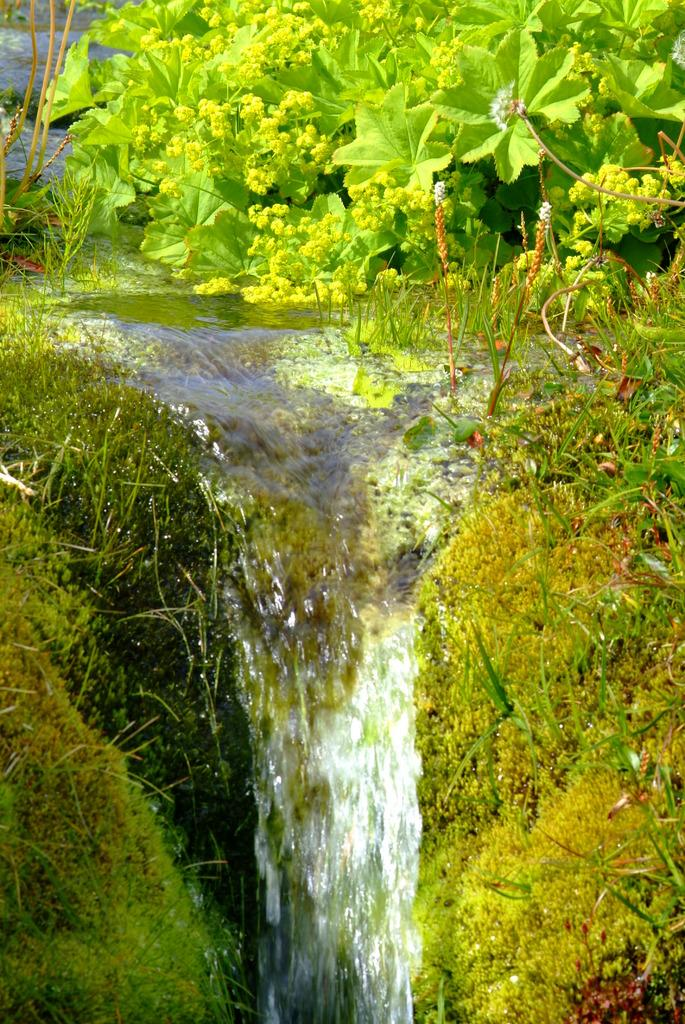What type of environment is depicted in the image? The image shows a natural environment with water, grass, and plants. Can you describe the water in the image? The water is visible in the image, but its specific characteristics are not mentioned. What type of vegetation can be seen in the image? There are plants and grass visible in the image. Can you see any ghosts in the image? There are no ghosts present in the image. What route do the plants take to grow in the image? The image does not show the growth process of the plants, so it is not possible to determine their route. 